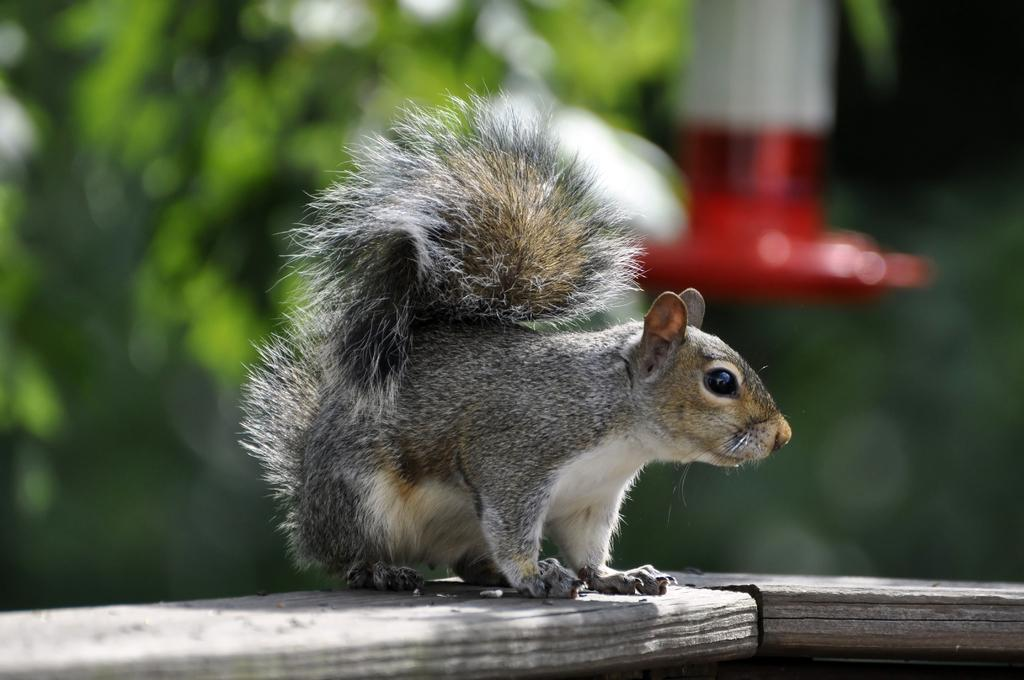What animal is present in the image? There is a squirrel in the image. What is the squirrel standing on? The squirrel is on a grey color surface. Can you describe the background of the image? The background of the image is blurred. How many kittens are playing with the squirrel's tail in the image? There are no kittens present in the image, and the squirrel's tail is not visible. 